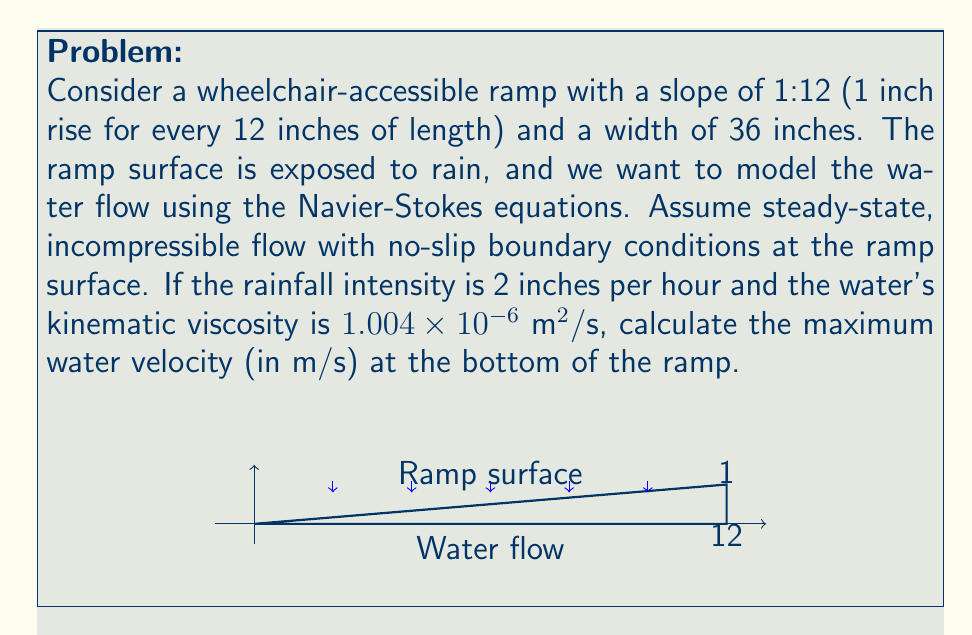Show me your answer to this math problem. To solve this problem, we'll use a simplified version of the Navier-Stokes equations for steady-state, incompressible flow on an inclined plane. We'll follow these steps:

1) First, we need to determine the flow depth. Using the continuity equation:

   $Q = V \cdot A$

   where $Q$ is the volumetric flow rate, $V$ is the average velocity, and $A$ is the cross-sectional area.

2) The rainfall intensity of 2 inches per hour is equivalent to:

   $2 \text{ in/hr} = 1.41 \times 10^{-5} \text{ m/s}$

3) For a 36-inch (0.9144 m) wide ramp, the volumetric flow rate at the bottom is:

   $Q = 1.41 \times 10^{-5} \text{ m/s} \cdot 0.9144 \text{ m} \cdot 12 \text{ m} = 1.55 \times 10^{-4} \text{ m}^3/\text{s}$

4) For thin film flow on an inclined plane, we can use the following equation derived from the Navier-Stokes equations:

   $u(y) = \frac{\rho g \sin\theta}{2\mu} y(2h-y)$

   where $u$ is the velocity, $\rho$ is the density of water, $g$ is gravitational acceleration, $\theta$ is the angle of inclination, $\mu$ is dynamic viscosity, $h$ is the flow depth, and $y$ is the distance from the ramp surface.

5) The maximum velocity occurs at the surface where $y=h$:

   $u_{max} = \frac{\rho g h^2 \sin\theta}{2\mu}$

6) We can relate the average velocity to the maximum velocity:

   $V_{avg} = \frac{2}{3}u_{max}$

7) From the continuity equation:

   $Q = V_{avg} \cdot A = \frac{2}{3}u_{max} \cdot (0.9144 \text{ m} \cdot h)$

8) Solving for $h$:

   $h = \sqrt[3]{\frac{3Q\mu}{0.9144 \rho g \sin\theta}}$

9) The angle $\theta$ for a 1:12 slope is:

   $\theta = \arctan(\frac{1}{12}) = 4.76°$

10) Substituting values ($\rho = 1000 \text{ kg/m}^3$, $g = 9.81 \text{ m/s}^2$, $\mu = 1.004 \times 10^{-3} \text{ Pa}\cdot\text{s}$):

    $h = \sqrt[3]{\frac{3 \cdot 1.55 \times 10^{-4} \cdot 1.004 \times 10^{-3}}{0.9144 \cdot 1000 \cdot 9.81 \cdot \sin(4.76°)}} = 0.00196 \text{ m}$

11) Now we can calculate the maximum velocity:

    $u_{max} = \frac{1000 \cdot 9.81 \cdot (0.00196)^2 \cdot \sin(4.76°)}{2 \cdot 1.004 \times 10^{-3}} = 0.159 \text{ m/s}$
Answer: $0.159 \text{ m/s}$ 